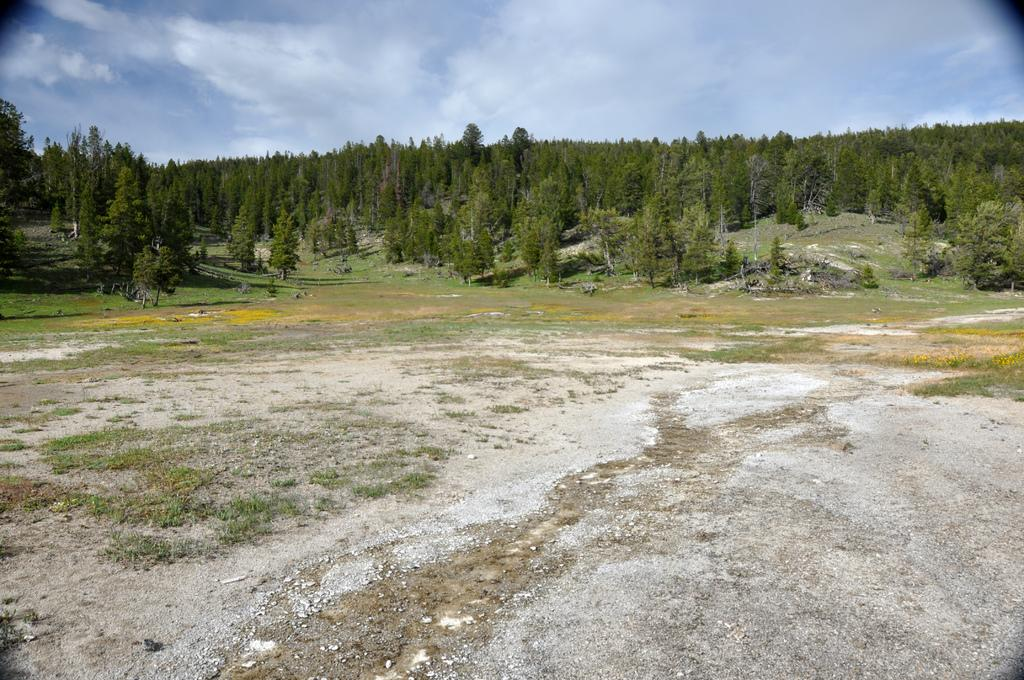What type of vegetation is visible in the image? There is grass in the image. What can be seen at the bottom of the image? There are stones at the bottom of the image. What is visible in the background of the image? There are trees in the background of the image. What is visible at the top of the image? The sky is visible in the image. What can be seen in the sky? Clouds are present in the sky. What type of advertisement can be seen on the grass in the image? There is no advertisement present on the grass in the image. What kind of rock is being used as a paperweight on the grass? There is no rock being used as a paperweight on the grass in the image. 